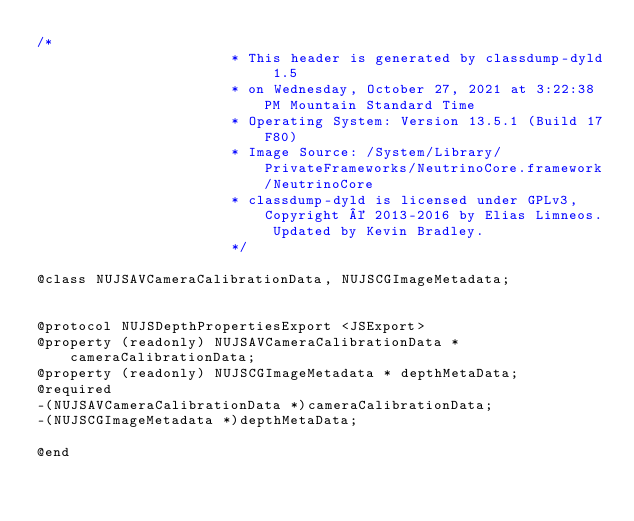Convert code to text. <code><loc_0><loc_0><loc_500><loc_500><_C_>/*
                       * This header is generated by classdump-dyld 1.5
                       * on Wednesday, October 27, 2021 at 3:22:38 PM Mountain Standard Time
                       * Operating System: Version 13.5.1 (Build 17F80)
                       * Image Source: /System/Library/PrivateFrameworks/NeutrinoCore.framework/NeutrinoCore
                       * classdump-dyld is licensed under GPLv3, Copyright © 2013-2016 by Elias Limneos. Updated by Kevin Bradley.
                       */

@class NUJSAVCameraCalibrationData, NUJSCGImageMetadata;


@protocol NUJSDepthPropertiesExport <JSExport>
@property (readonly) NUJSAVCameraCalibrationData * cameraCalibrationData; 
@property (readonly) NUJSCGImageMetadata * depthMetaData; 
@required
-(NUJSAVCameraCalibrationData *)cameraCalibrationData;
-(NUJSCGImageMetadata *)depthMetaData;

@end

</code> 